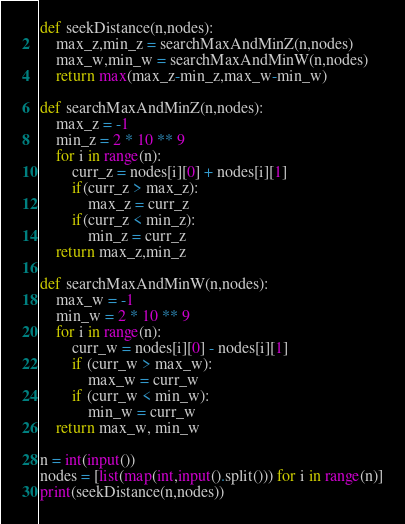Convert code to text. <code><loc_0><loc_0><loc_500><loc_500><_Python_>def seekDistance(n,nodes):
    max_z,min_z = searchMaxAndMinZ(n,nodes)
    max_w,min_w = searchMaxAndMinW(n,nodes)
    return max(max_z-min_z,max_w-min_w)

def searchMaxAndMinZ(n,nodes):
    max_z = -1
    min_z = 2 * 10 ** 9
    for i in range(n):
        curr_z = nodes[i][0] + nodes[i][1]
        if(curr_z > max_z):
            max_z = curr_z
        if(curr_z < min_z):
            min_z = curr_z
    return max_z,min_z

def searchMaxAndMinW(n,nodes):
    max_w = -1
    min_w = 2 * 10 ** 9
    for i in range(n):
        curr_w = nodes[i][0] - nodes[i][1]
        if (curr_w > max_w):
            max_w = curr_w
        if (curr_w < min_w):
            min_w = curr_w
    return max_w, min_w

n = int(input())
nodes = [list(map(int,input().split())) for i in range(n)]
print(seekDistance(n,nodes))</code> 